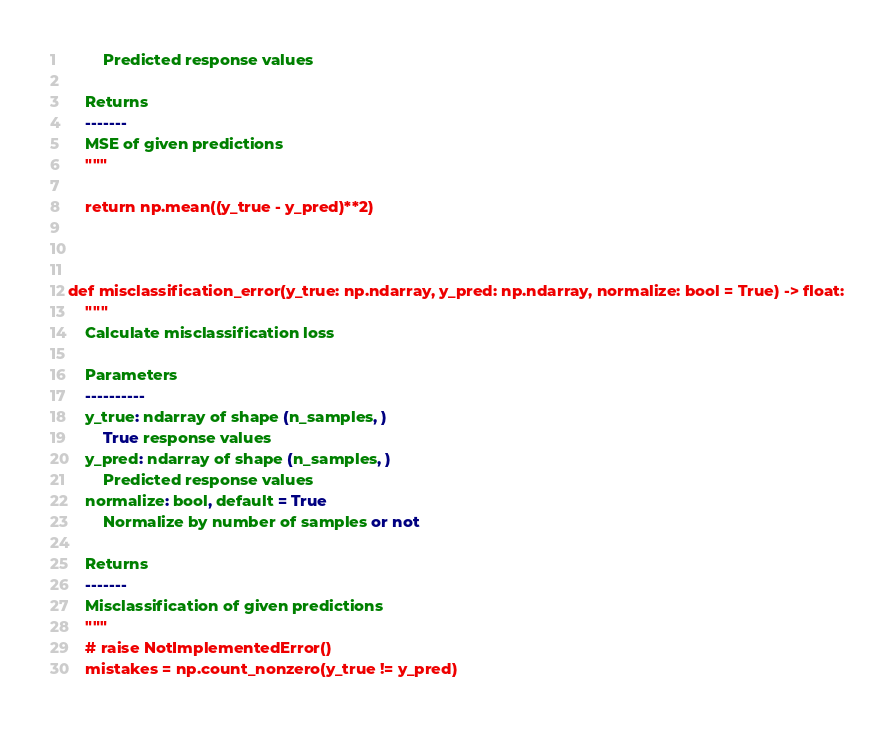Convert code to text. <code><loc_0><loc_0><loc_500><loc_500><_Python_>        Predicted response values

    Returns
    -------
    MSE of given predictions
    """

    return np.mean((y_true - y_pred)**2)
    


def misclassification_error(y_true: np.ndarray, y_pred: np.ndarray, normalize: bool = True) -> float:
    """
    Calculate misclassification loss

    Parameters
    ----------
    y_true: ndarray of shape (n_samples, )
        True response values
    y_pred: ndarray of shape (n_samples, )
        Predicted response values
    normalize: bool, default = True
        Normalize by number of samples or not

    Returns
    -------
    Misclassification of given predictions
    """
    # raise NotImplementedError()
    mistakes = np.count_nonzero(y_true != y_pred)</code> 